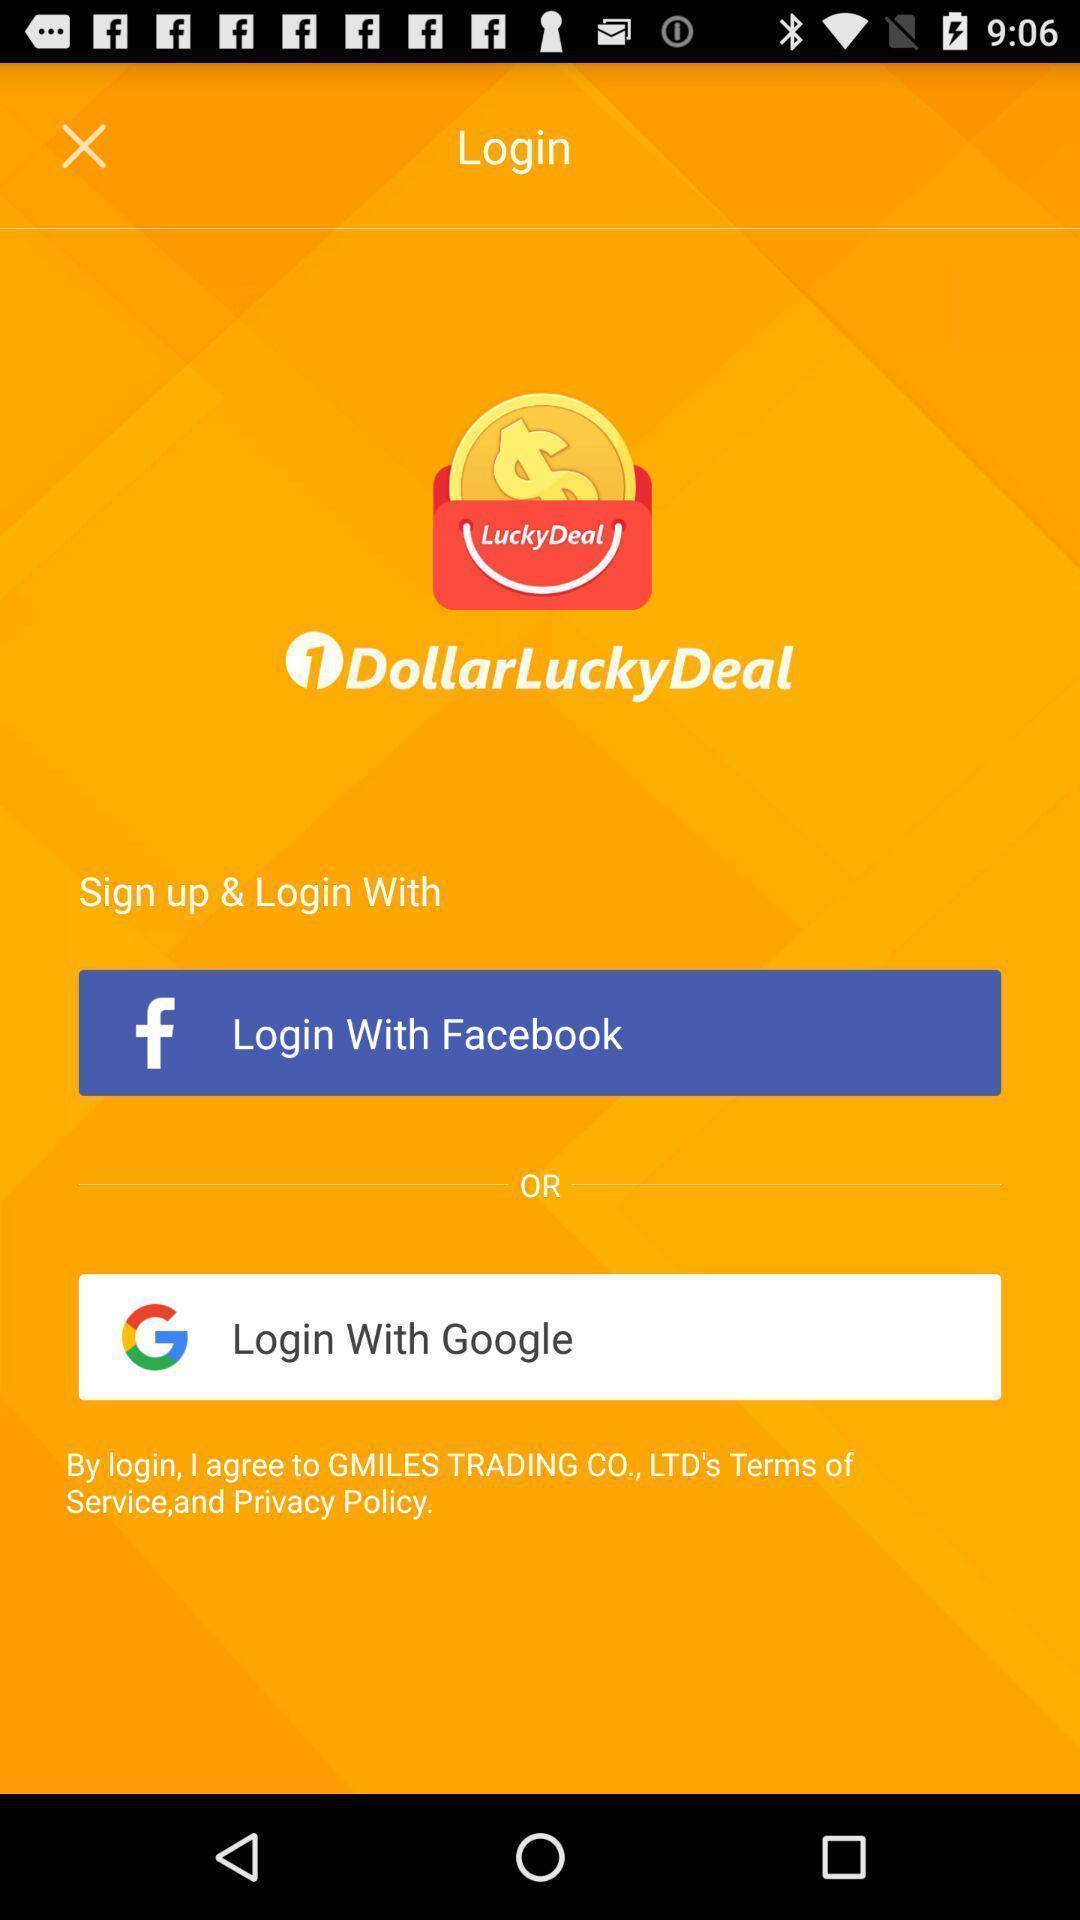Give me a narrative description of this picture. Welcome page for a deals based app. 